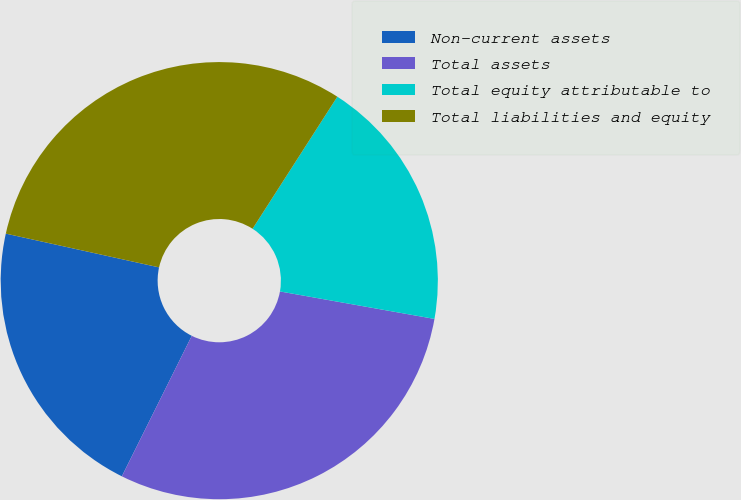Convert chart. <chart><loc_0><loc_0><loc_500><loc_500><pie_chart><fcel>Non-current assets<fcel>Total assets<fcel>Total equity attributable to<fcel>Total liabilities and equity<nl><fcel>21.1%<fcel>29.55%<fcel>18.72%<fcel>30.63%<nl></chart> 